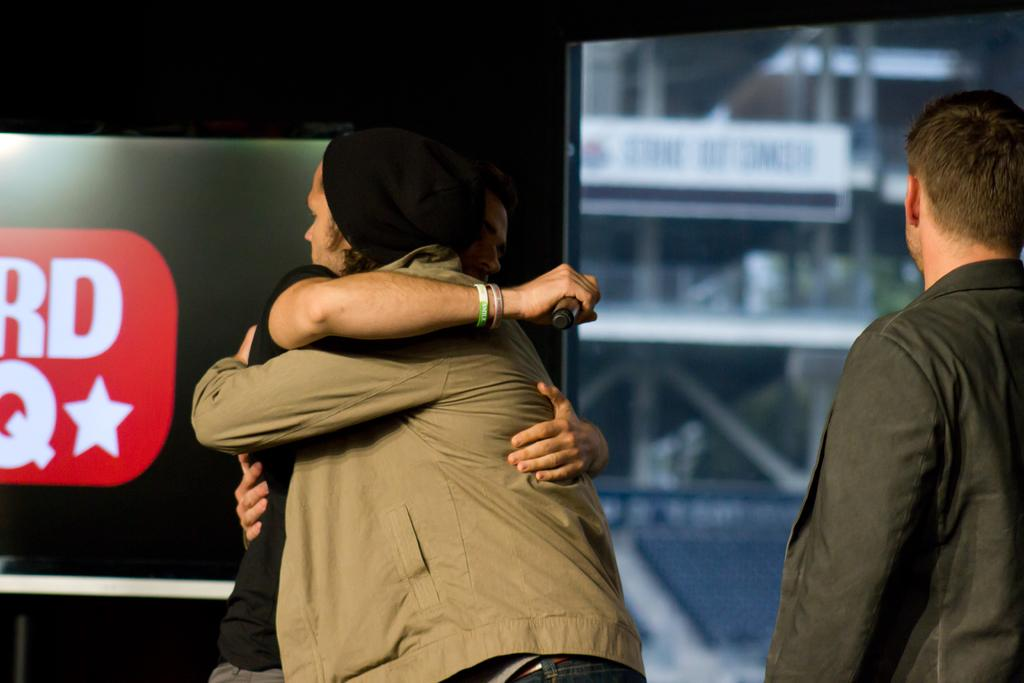What are the two people in the image doing? The two people in the image are hugging. Is there anyone else in the image besides the two people hugging? Yes, there is another person standing nearby. What can be seen in the background of the image? There is a television and a banner in the background of the image. What type of plough is being used to harvest crops in the image? There is no plough present in the image; it features two people hugging and a background with a television and a banner. 